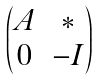<formula> <loc_0><loc_0><loc_500><loc_500>\begin{pmatrix} A & * \\ 0 & - I \end{pmatrix}</formula> 